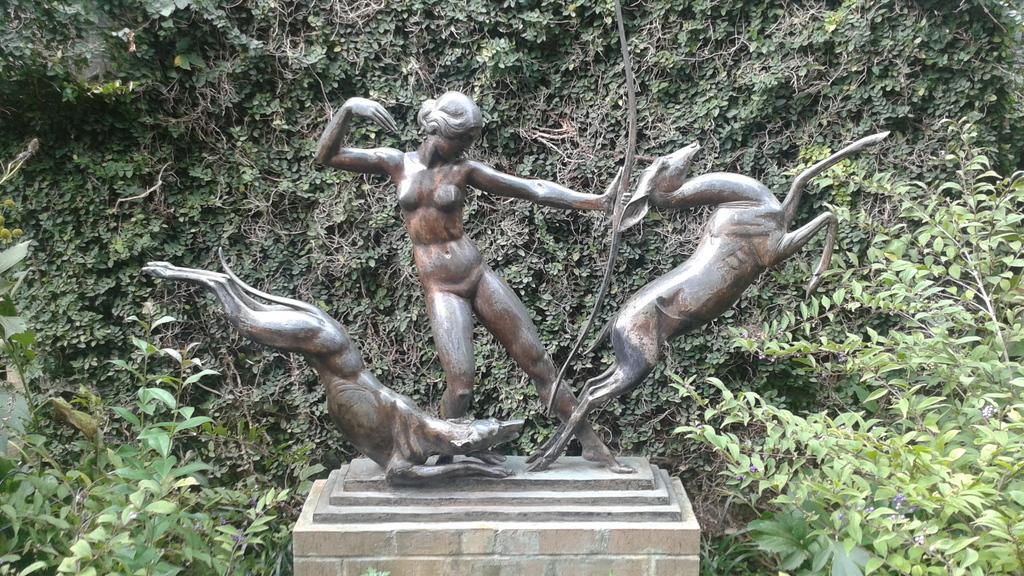Could you give a brief overview of what you see in this image? In this image, we can see some statues on an object. We can also see some plants. 